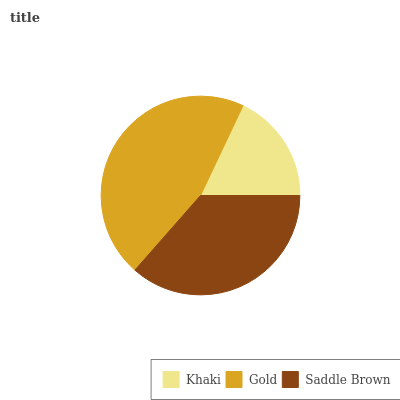Is Khaki the minimum?
Answer yes or no. Yes. Is Gold the maximum?
Answer yes or no. Yes. Is Saddle Brown the minimum?
Answer yes or no. No. Is Saddle Brown the maximum?
Answer yes or no. No. Is Gold greater than Saddle Brown?
Answer yes or no. Yes. Is Saddle Brown less than Gold?
Answer yes or no. Yes. Is Saddle Brown greater than Gold?
Answer yes or no. No. Is Gold less than Saddle Brown?
Answer yes or no. No. Is Saddle Brown the high median?
Answer yes or no. Yes. Is Saddle Brown the low median?
Answer yes or no. Yes. Is Gold the high median?
Answer yes or no. No. Is Gold the low median?
Answer yes or no. No. 